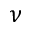Convert formula to latex. <formula><loc_0><loc_0><loc_500><loc_500>\nu</formula> 